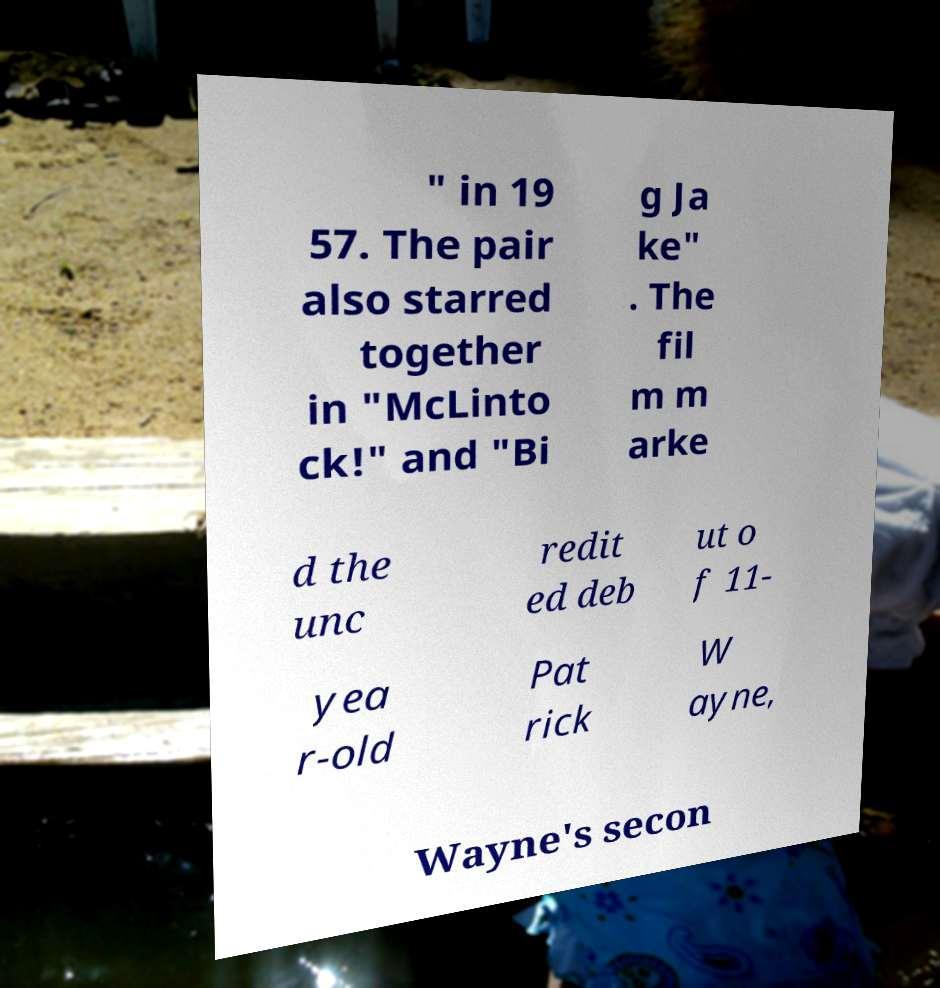Can you accurately transcribe the text from the provided image for me? " in 19 57. The pair also starred together in "McLinto ck!" and "Bi g Ja ke" . The fil m m arke d the unc redit ed deb ut o f 11- yea r-old Pat rick W ayne, Wayne's secon 